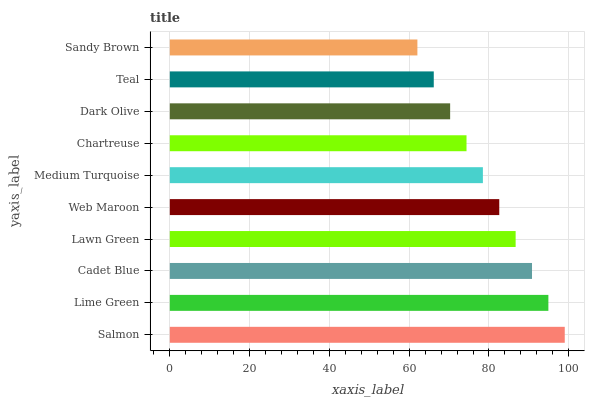Is Sandy Brown the minimum?
Answer yes or no. Yes. Is Salmon the maximum?
Answer yes or no. Yes. Is Lime Green the minimum?
Answer yes or no. No. Is Lime Green the maximum?
Answer yes or no. No. Is Salmon greater than Lime Green?
Answer yes or no. Yes. Is Lime Green less than Salmon?
Answer yes or no. Yes. Is Lime Green greater than Salmon?
Answer yes or no. No. Is Salmon less than Lime Green?
Answer yes or no. No. Is Web Maroon the high median?
Answer yes or no. Yes. Is Medium Turquoise the low median?
Answer yes or no. Yes. Is Dark Olive the high median?
Answer yes or no. No. Is Teal the low median?
Answer yes or no. No. 